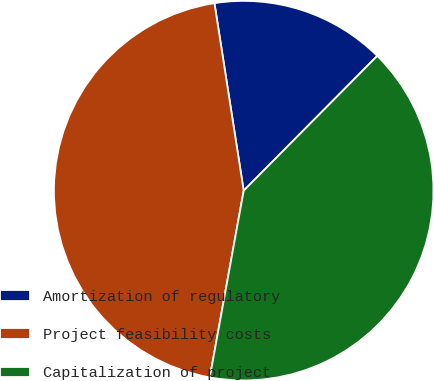<chart> <loc_0><loc_0><loc_500><loc_500><pie_chart><fcel>Amortization of regulatory<fcel>Project feasibility costs<fcel>Capitalization of project<nl><fcel>14.89%<fcel>44.68%<fcel>40.43%<nl></chart> 